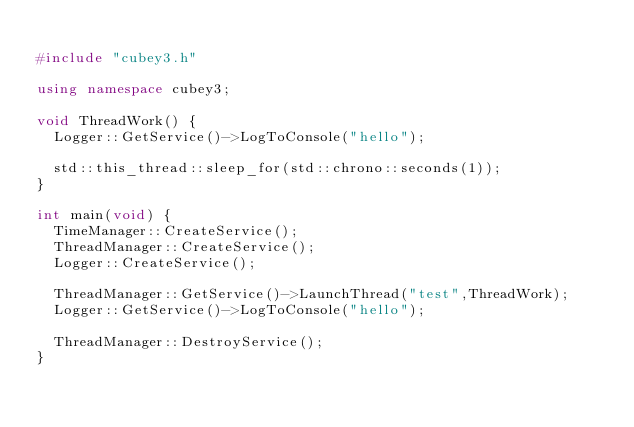Convert code to text. <code><loc_0><loc_0><loc_500><loc_500><_C++_>
#include "cubey3.h"

using namespace cubey3;

void ThreadWork() {
	Logger::GetService()->LogToConsole("hello");

	std::this_thread::sleep_for(std::chrono::seconds(1));
}

int main(void) {
	TimeManager::CreateService();
	ThreadManager::CreateService();
	Logger::CreateService();

	ThreadManager::GetService()->LaunchThread("test",ThreadWork);
	Logger::GetService()->LogToConsole("hello");

	ThreadManager::DestroyService();
}</code> 